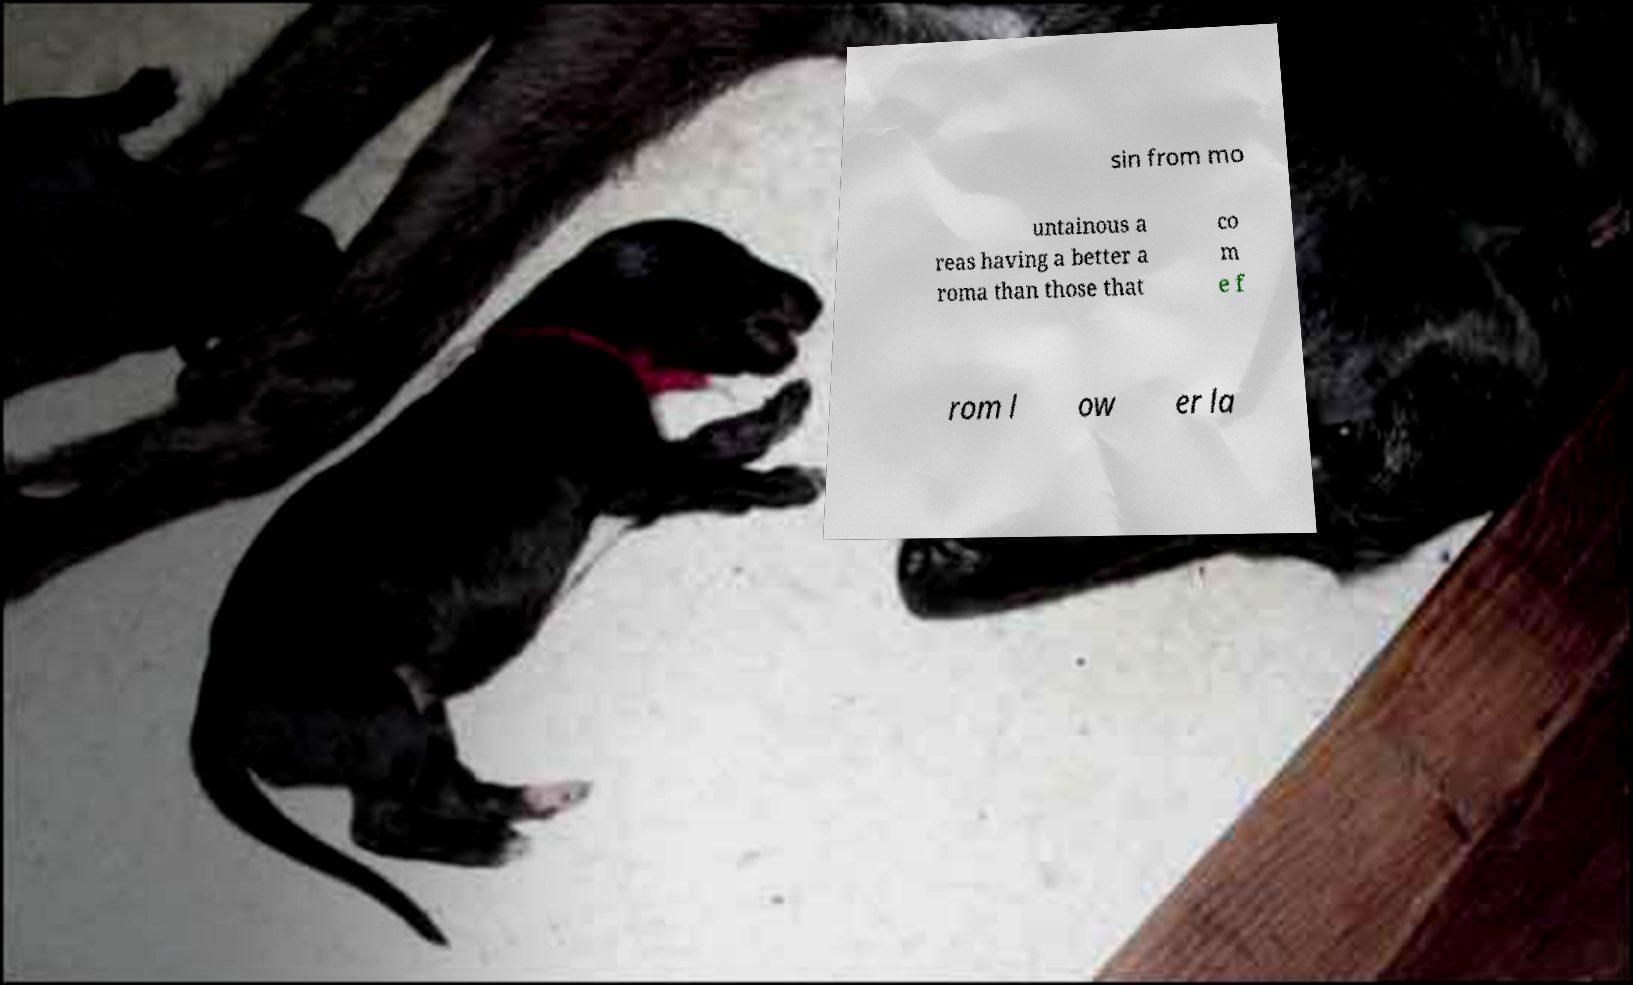There's text embedded in this image that I need extracted. Can you transcribe it verbatim? sin from mo untainous a reas having a better a roma than those that co m e f rom l ow er la 